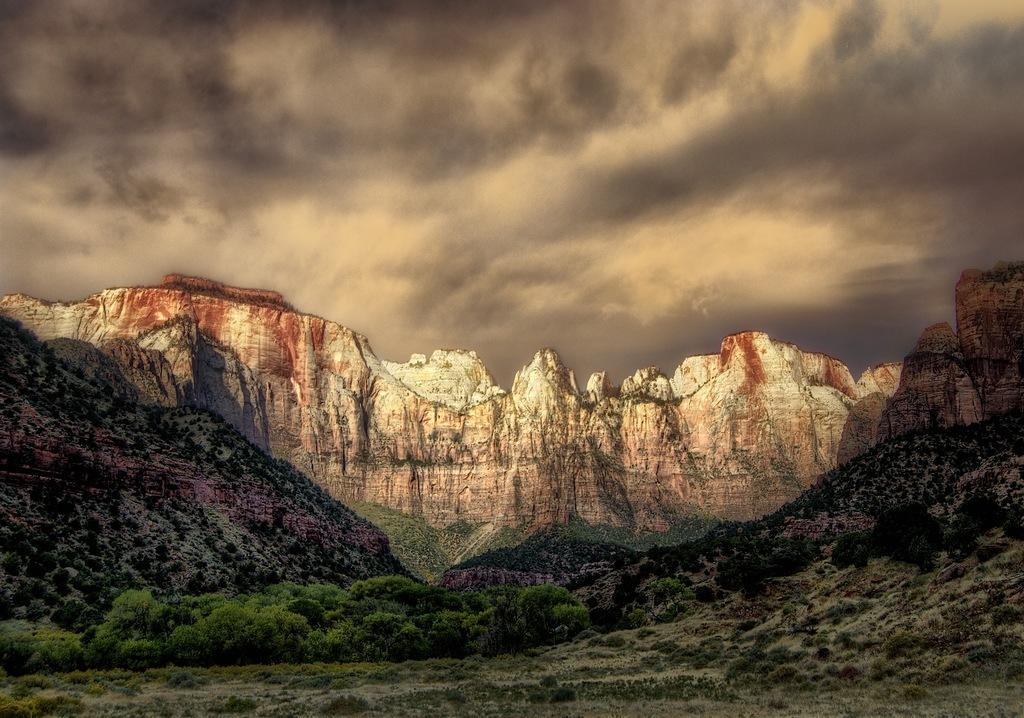What type of natural features can be seen in the image? There are trees and mountains in the image. What part of the natural environment is visible in the image? The sky is visible in the image. What type of stem can be seen growing from the trees in the image? There is no stem growing from the trees in the image; the trees are depicted as a whole. 